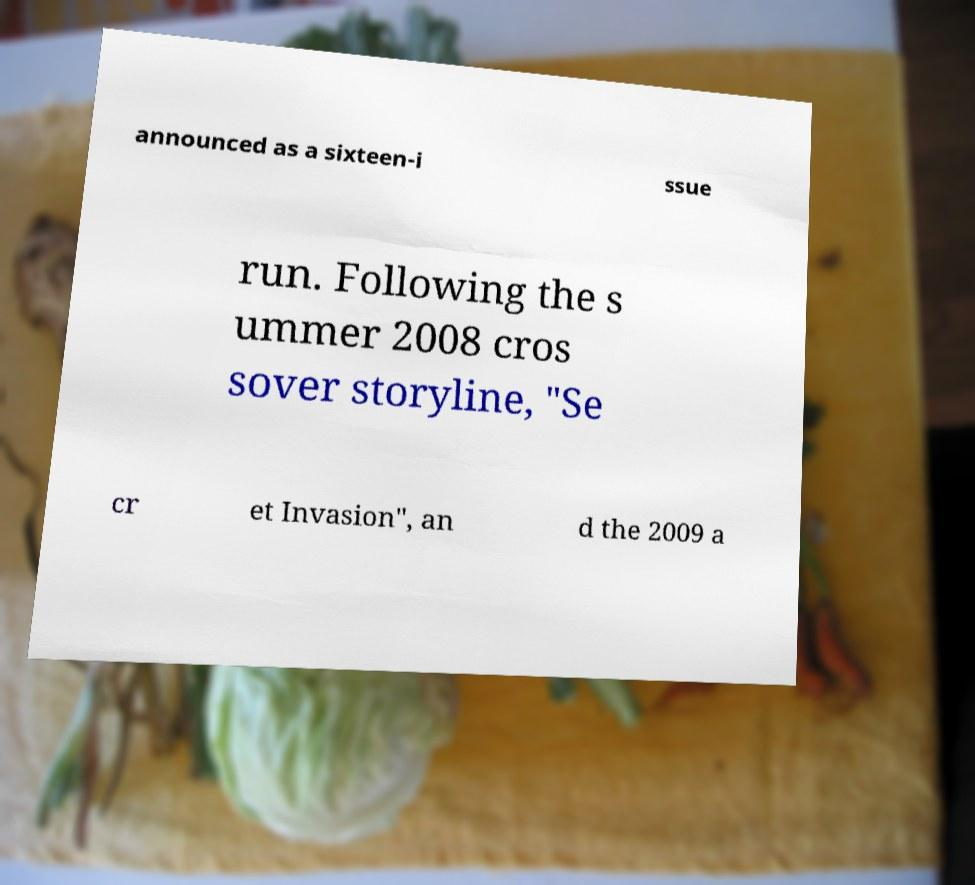There's text embedded in this image that I need extracted. Can you transcribe it verbatim? announced as a sixteen-i ssue run. Following the s ummer 2008 cros sover storyline, "Se cr et Invasion", an d the 2009 a 